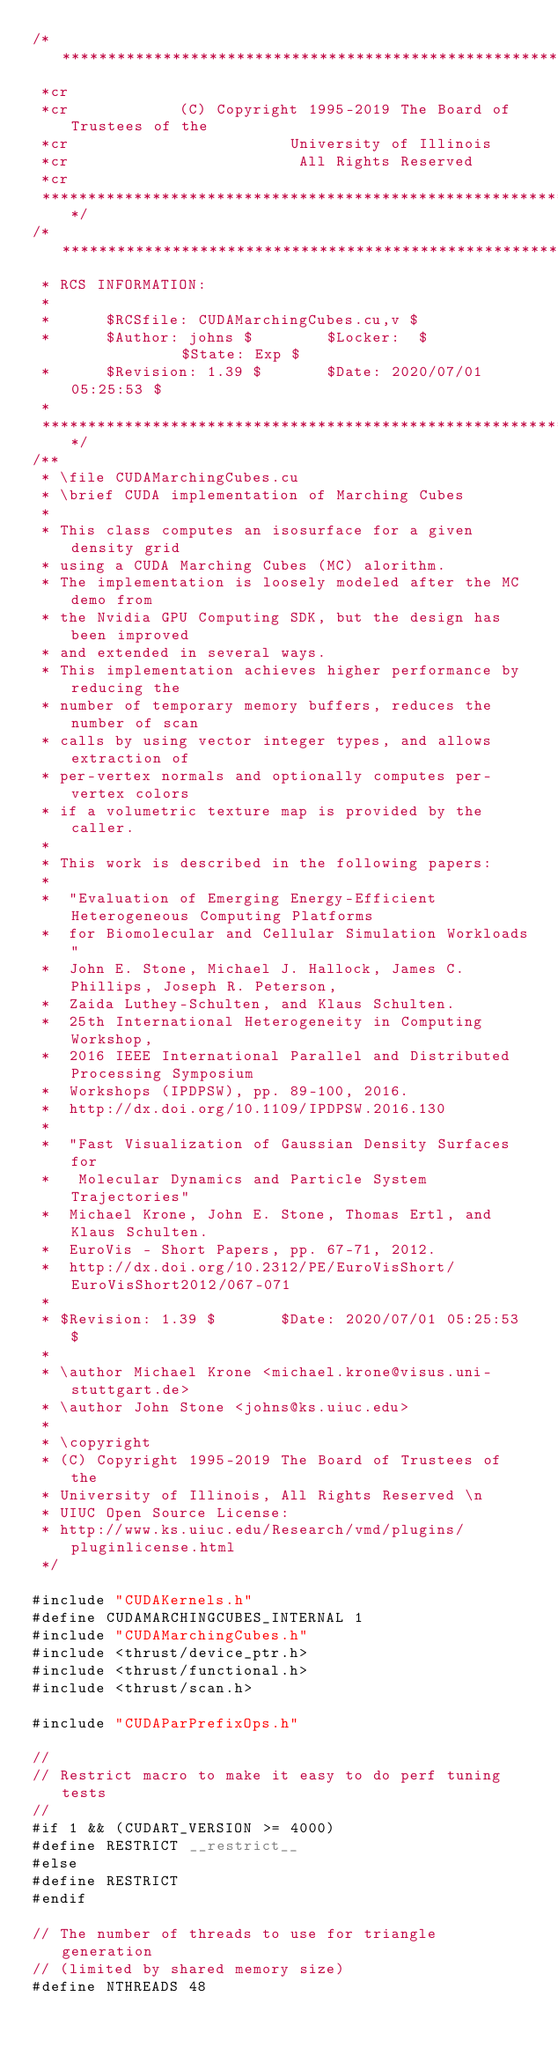Convert code to text. <code><loc_0><loc_0><loc_500><loc_500><_Cuda_>/***************************************************************************
 *cr
 *cr            (C) Copyright 1995-2019 The Board of Trustees of the
 *cr                        University of Illinois
 *cr                         All Rights Reserved
 *cr
 ***************************************************************************/
/***************************************************************************
 * RCS INFORMATION:
 *
 *      $RCSfile: CUDAMarchingCubes.cu,v $
 *      $Author: johns $        $Locker:  $             $State: Exp $
 *      $Revision: 1.39 $       $Date: 2020/07/01 05:25:53 $
 *
 ***************************************************************************/
/**
 * \file CUDAMarchingCubes.cu
 * \brief CUDA implementation of Marching Cubes
 *
 * This class computes an isosurface for a given density grid
 * using a CUDA Marching Cubes (MC) alorithm.
 * The implementation is loosely modeled after the MC demo from
 * the Nvidia GPU Computing SDK, but the design has been improved
 * and extended in several ways.
 * This implementation achieves higher performance by reducing the
 * number of temporary memory buffers, reduces the number of scan
 * calls by using vector integer types, and allows extraction of
 * per-vertex normals and optionally computes per-vertex colors
 * if a volumetric texture map is provided by the caller.
 *
 * This work is described in the following papers:
 *
 *  "Evaluation of Emerging Energy-Efficient Heterogeneous Computing Platforms
 *  for Biomolecular and Cellular Simulation Workloads"
 *  John E. Stone, Michael J. Hallock, James C. Phillips, Joseph R. Peterson,
 *  Zaida Luthey-Schulten, and Klaus Schulten.
 *  25th International Heterogeneity in Computing Workshop,
 *  2016 IEEE International Parallel and Distributed Processing Symposium
 *  Workshops (IPDPSW), pp. 89-100, 2016.
 *  http://dx.doi.org/10.1109/IPDPSW.2016.130
 *
 *  "Fast Visualization of Gaussian Density Surfaces for
 *   Molecular Dynamics and Particle System Trajectories"
 *  Michael Krone, John E. Stone, Thomas Ertl, and Klaus Schulten.
 *  EuroVis - Short Papers, pp. 67-71, 2012.
 *  http://dx.doi.org/10.2312/PE/EuroVisShort/EuroVisShort2012/067-071
 *
 * $Revision: 1.39 $       $Date: 2020/07/01 05:25:53 $
 *
 * \author Michael Krone <michael.krone@visus.uni-stuttgart.de>
 * \author John Stone <johns@ks.uiuc.edu>
 *
 * \copyright
 * (C) Copyright 1995-2019 The Board of Trustees of the
 * University of Illinois, All Rights Reserved \n
 * UIUC Open Source License:
 * http://www.ks.uiuc.edu/Research/vmd/plugins/pluginlicense.html
 */

#include "CUDAKernels.h"
#define CUDAMARCHINGCUBES_INTERNAL 1
#include "CUDAMarchingCubes.h"
#include <thrust/device_ptr.h>
#include <thrust/functional.h>
#include <thrust/scan.h>

#include "CUDAParPrefixOps.h"

//
// Restrict macro to make it easy to do perf tuning tests
//
#if 1 && (CUDART_VERSION >= 4000)
#define RESTRICT __restrict__
#else
#define RESTRICT
#endif

// The number of threads to use for triangle generation
// (limited by shared memory size)
#define NTHREADS 48
</code> 